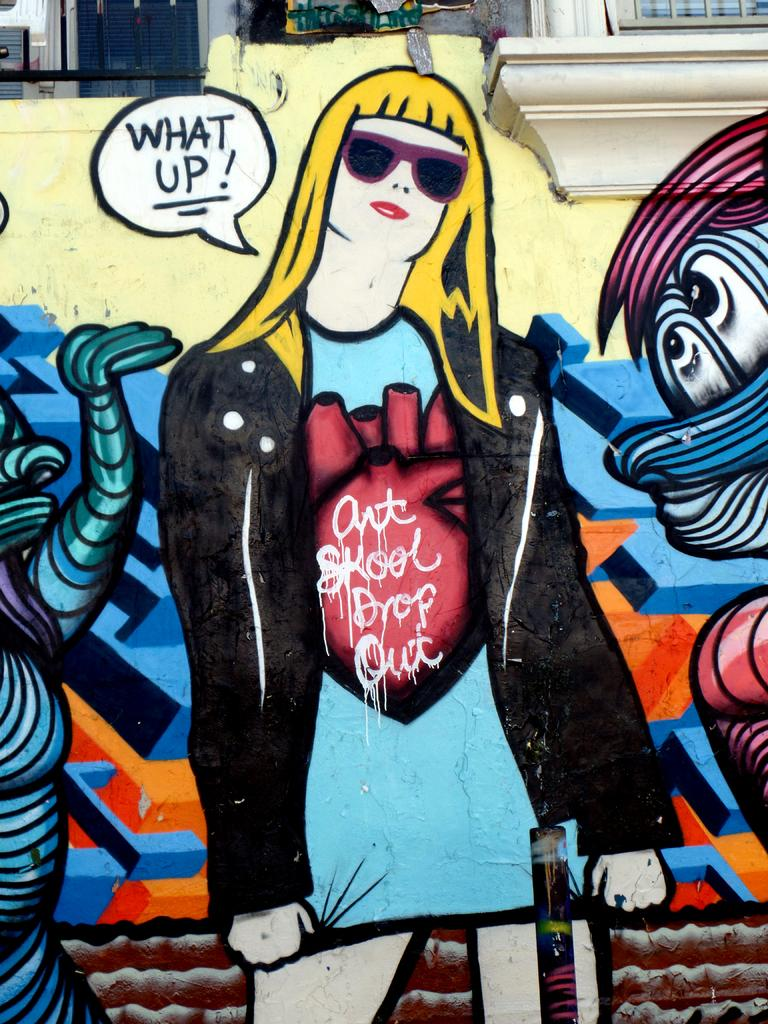What type of character is in the image? There is a cartoon person in the image. What is the cartoon person wearing? The cartoon person is wearing a black and blue dress. What can be seen in the background of the image? There is a colorful wall and two windows in the background of the image. What type of tank is visible in the image? There is no tank present in the image; it features a cartoon person wearing a black and blue dress in front of a colorful wall with two windows. 